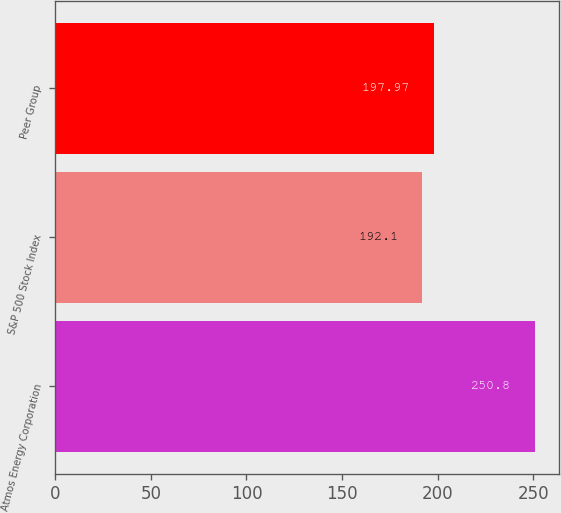Convert chart to OTSL. <chart><loc_0><loc_0><loc_500><loc_500><bar_chart><fcel>Atmos Energy Corporation<fcel>S&P 500 Stock Index<fcel>Peer Group<nl><fcel>250.8<fcel>192.1<fcel>197.97<nl></chart> 